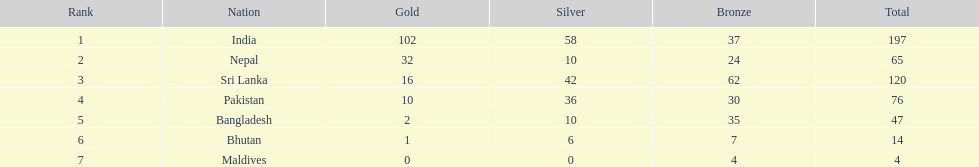What is the variation in the total quantity of medals between india and nepal? 132. 